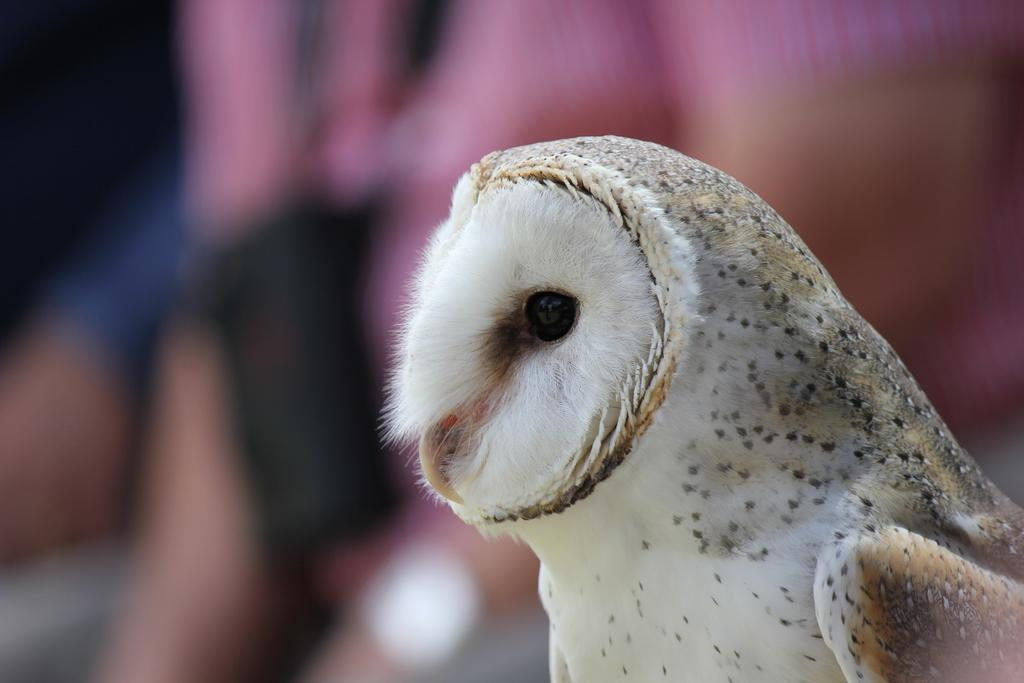What type of animal can be seen in the image? There is a bird in the image. Can you describe the background of the image? The background of the image is blurred. Are there any bells attached to the bird in the image? There are no bells present in the image, and the bird does not have any visible attachments. 